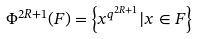Convert formula to latex. <formula><loc_0><loc_0><loc_500><loc_500>\Phi ^ { 2 R + 1 } ( F ) = \left \{ x ^ { q ^ { 2 R + 1 } } | x \in F \right \}</formula> 